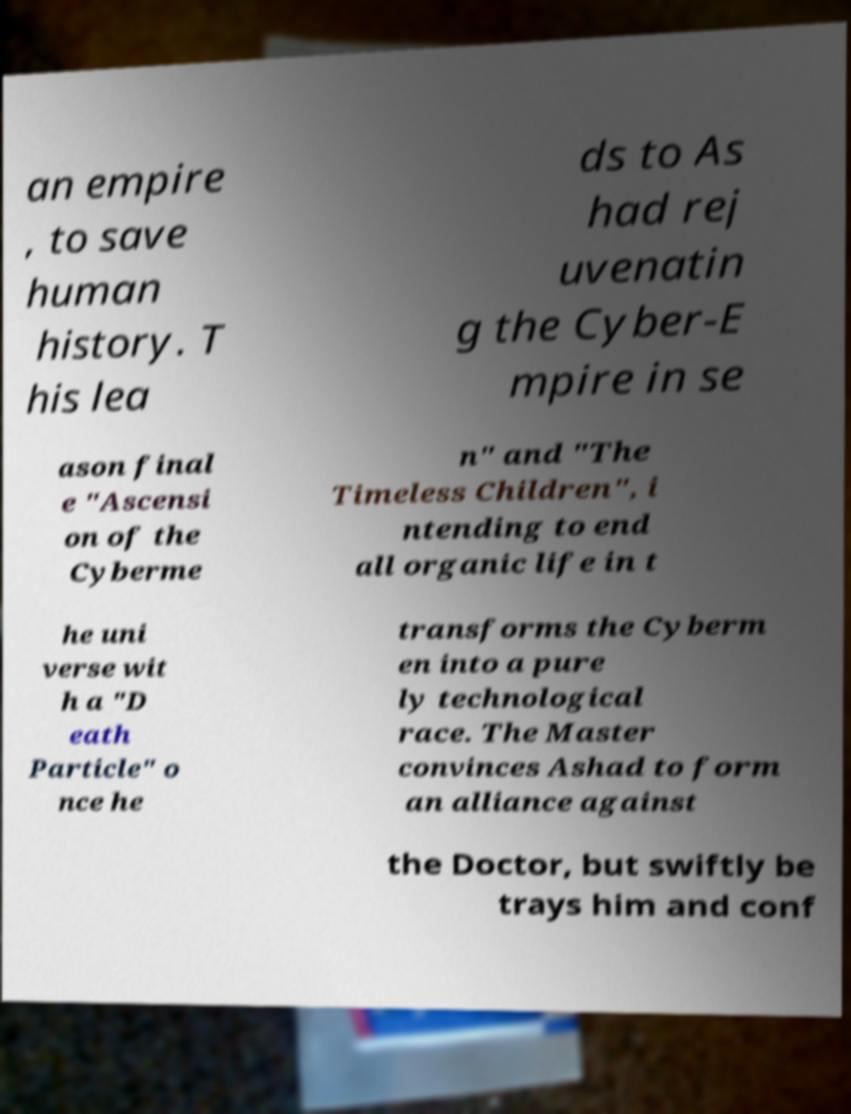For documentation purposes, I need the text within this image transcribed. Could you provide that? an empire , to save human history. T his lea ds to As had rej uvenatin g the Cyber-E mpire in se ason final e "Ascensi on of the Cyberme n" and "The Timeless Children", i ntending to end all organic life in t he uni verse wit h a "D eath Particle" o nce he transforms the Cyberm en into a pure ly technological race. The Master convinces Ashad to form an alliance against the Doctor, but swiftly be trays him and conf 